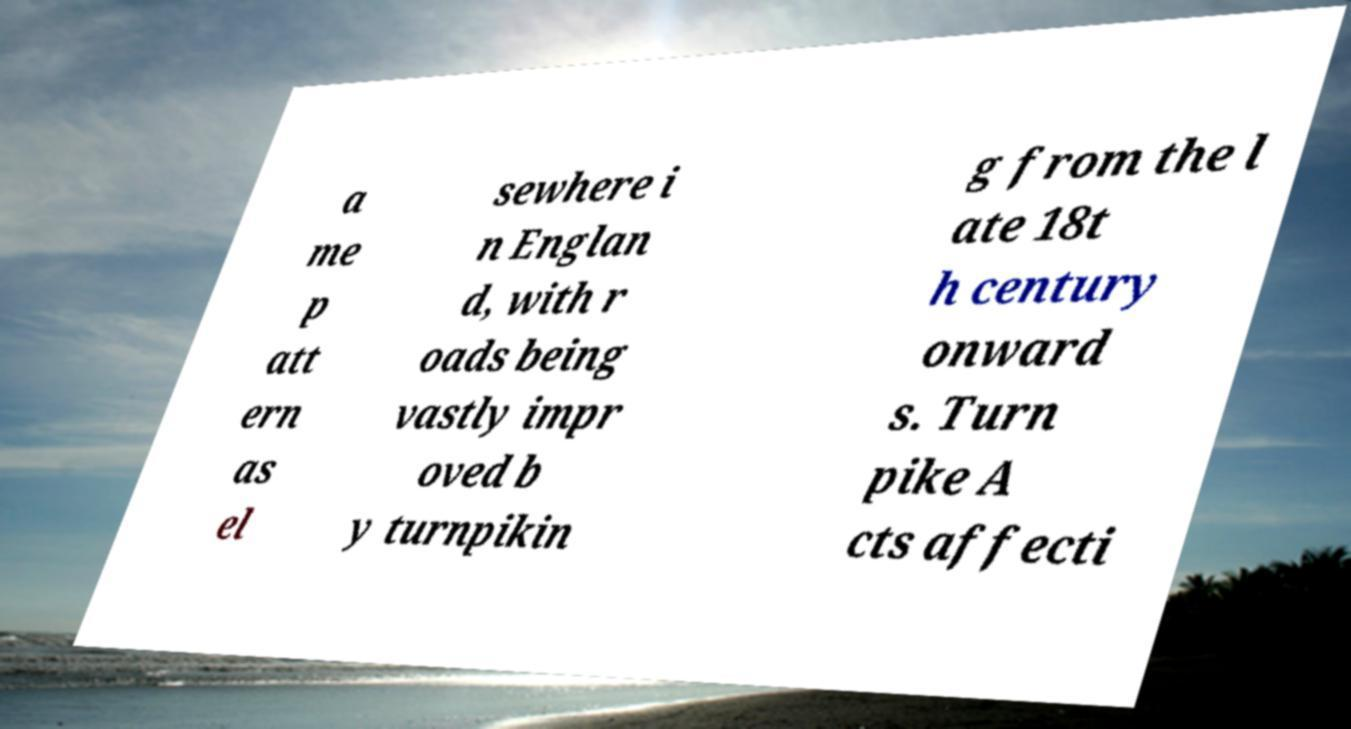Can you accurately transcribe the text from the provided image for me? a me p att ern as el sewhere i n Englan d, with r oads being vastly impr oved b y turnpikin g from the l ate 18t h century onward s. Turn pike A cts affecti 